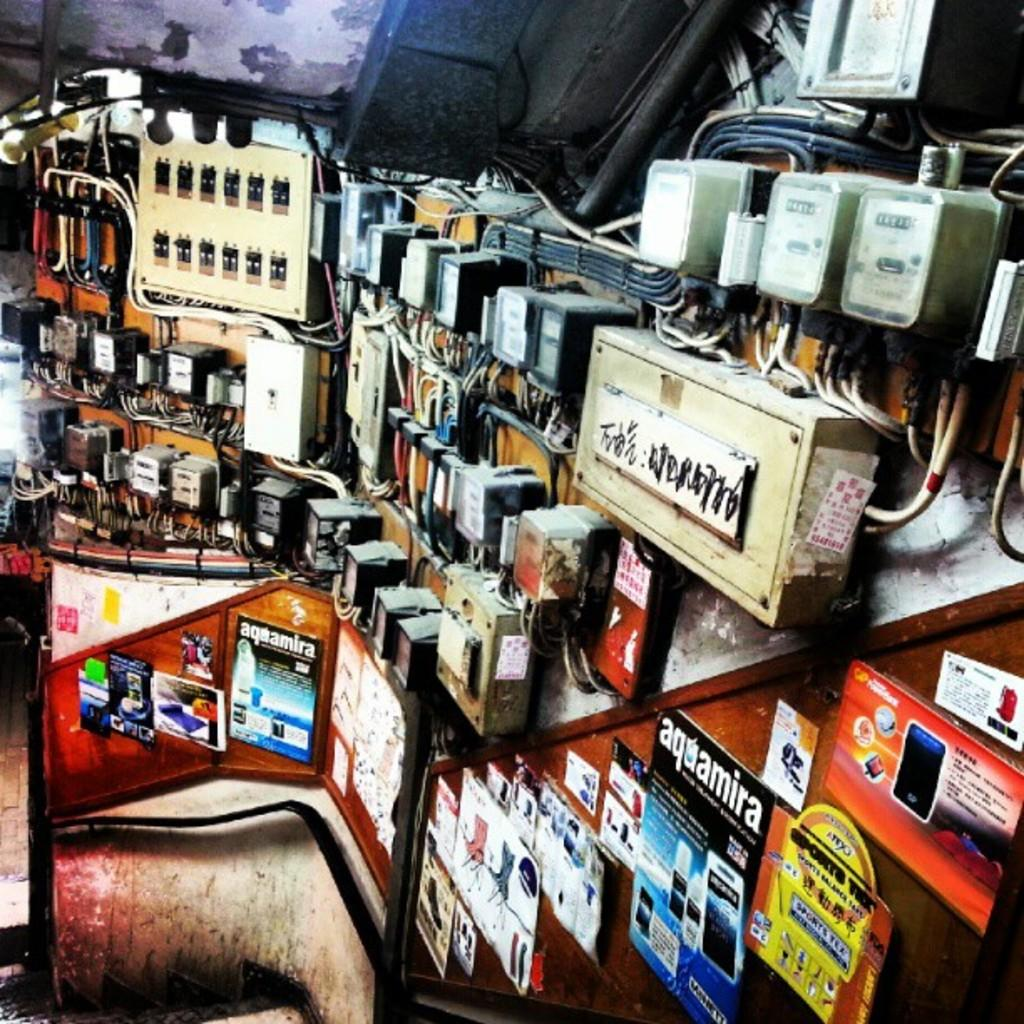What type of equipment can be seen in the image? There are electric meters in the image. What else is present in the image besides the electric meters? There are wires and junction boxes visible in the image. Are there any decorative elements in the image? Yes, there are posters attached to the wall in the image. How does the toe of the person in the image help with the adjustment of the electric meters? There is no person present in the image, and therefore no toe or adjustment of electric meters can be observed. 